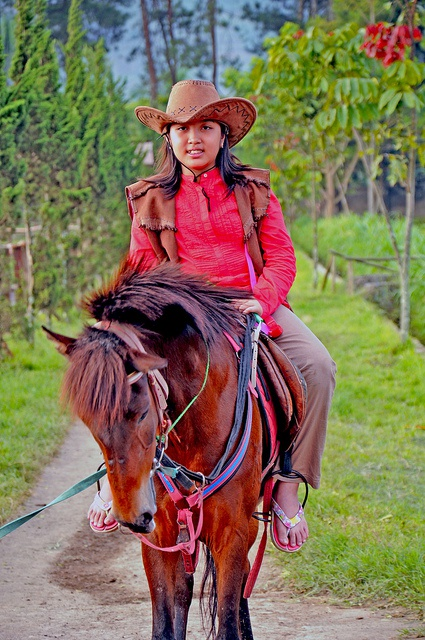Describe the objects in this image and their specific colors. I can see horse in gray, maroon, black, and brown tones and people in gray, brown, salmon, and darkgray tones in this image. 